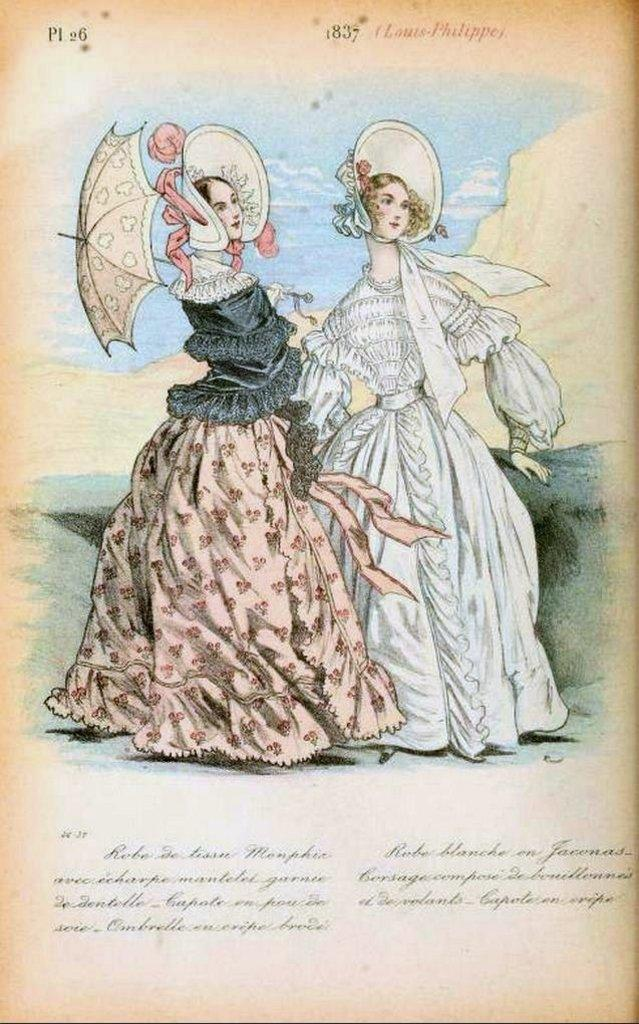What is featured in the image? There is a poster in the image. What is depicted on the poster? The poster includes two girls. What type of pen is the girl holding in the image? There is no pen visible in the image; the poster only includes two girls. What kind of bird can be seen flying in the image? There are no birds present in the image; it only features a poster with two girls. 